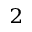<formula> <loc_0><loc_0><loc_500><loc_500>_ { 2 }</formula> 